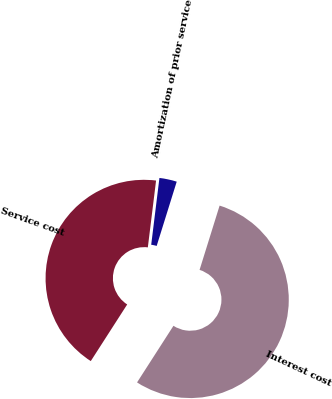Convert chart. <chart><loc_0><loc_0><loc_500><loc_500><pie_chart><fcel>Service cost<fcel>Interest cost<fcel>Amortization of prior service<nl><fcel>42.86%<fcel>54.29%<fcel>2.86%<nl></chart> 